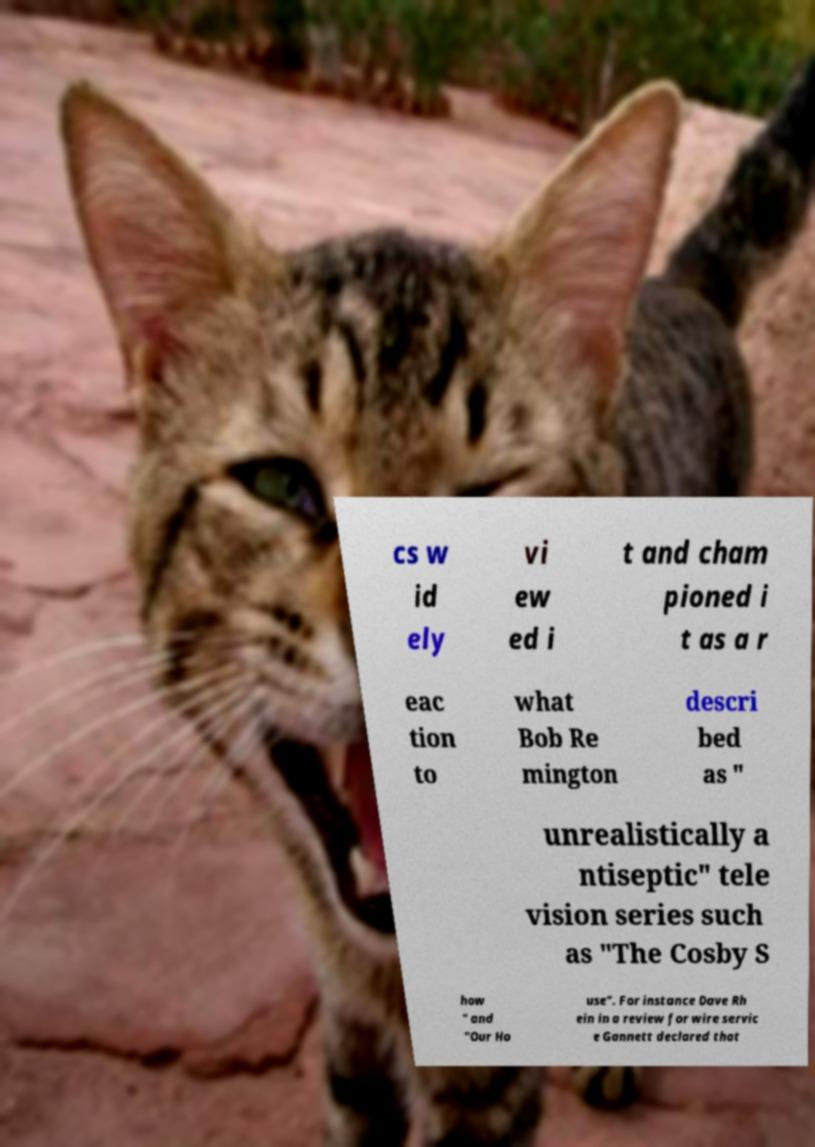Can you read and provide the text displayed in the image?This photo seems to have some interesting text. Can you extract and type it out for me? cs w id ely vi ew ed i t and cham pioned i t as a r eac tion to what Bob Re mington descri bed as " unrealistically a ntiseptic" tele vision series such as "The Cosby S how " and "Our Ho use". For instance Dave Rh ein in a review for wire servic e Gannett declared that 